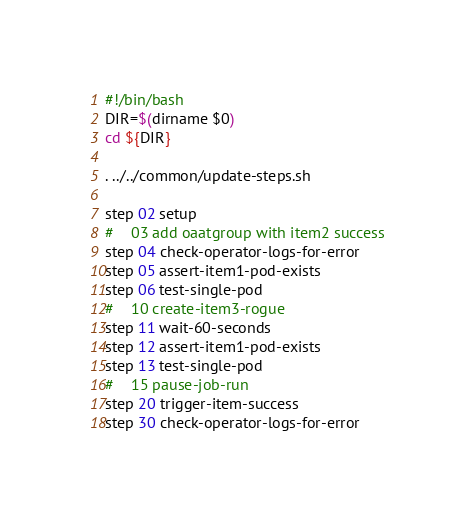Convert code to text. <code><loc_0><loc_0><loc_500><loc_500><_Bash_>#!/bin/bash
DIR=$(dirname $0)
cd ${DIR}

. ../../common/update-steps.sh

step 02 setup
#    03 add oaatgroup with item2 success
step 04 check-operator-logs-for-error
step 05 assert-item1-pod-exists
step 06 test-single-pod
#    10 create-item3-rogue
step 11 wait-60-seconds
step 12 assert-item1-pod-exists
step 13 test-single-pod
#    15 pause-job-run
step 20 trigger-item-success
step 30 check-operator-logs-for-error
</code> 